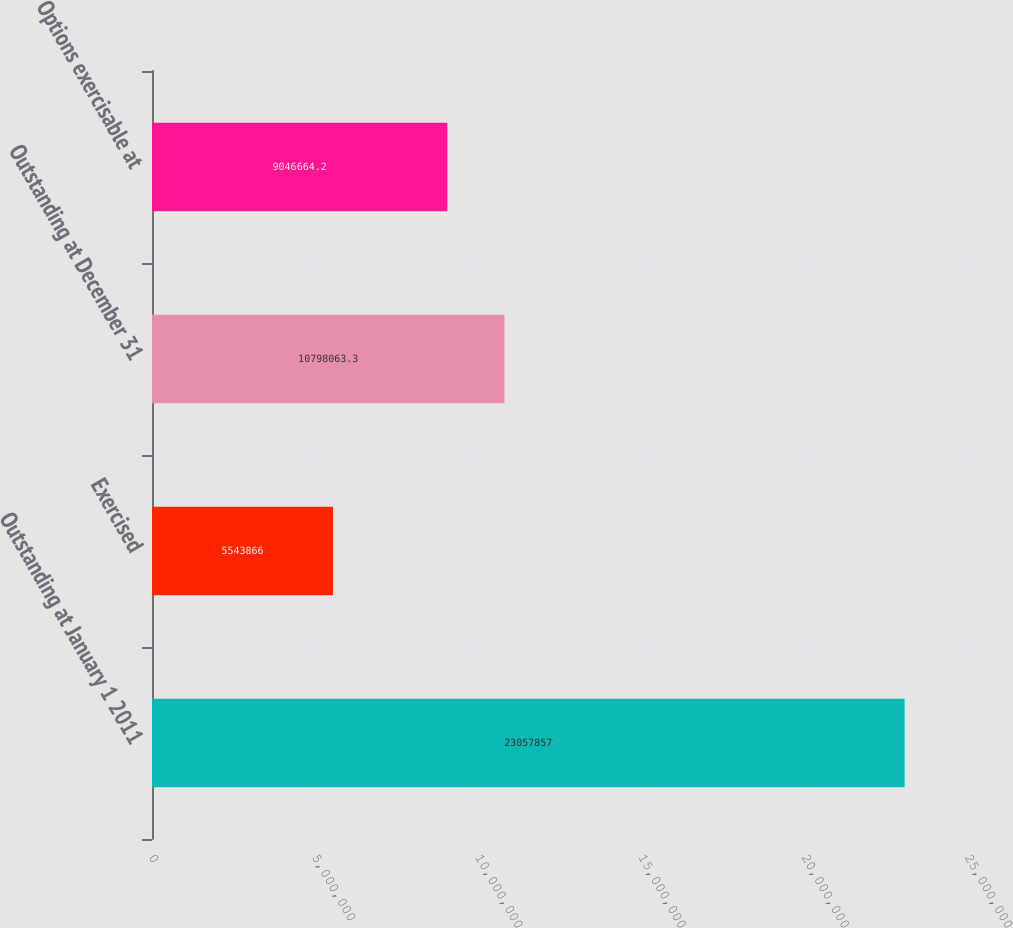<chart> <loc_0><loc_0><loc_500><loc_500><bar_chart><fcel>Outstanding at January 1 2011<fcel>Exercised<fcel>Outstanding at December 31<fcel>Options exercisable at<nl><fcel>2.30579e+07<fcel>5.54387e+06<fcel>1.07981e+07<fcel>9.04666e+06<nl></chart> 